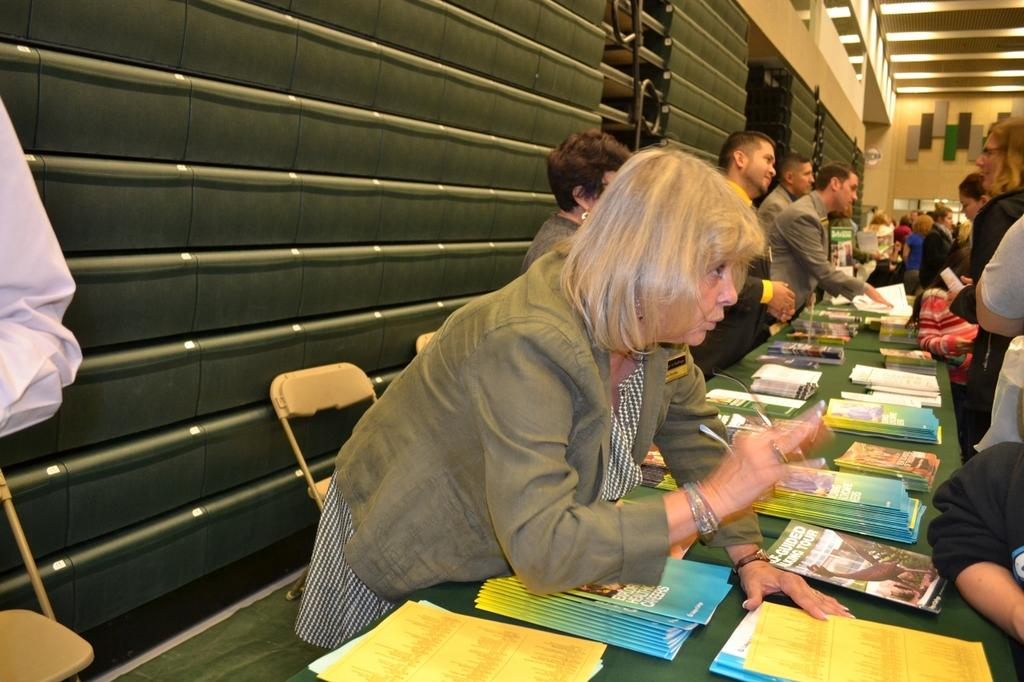Who or what is present in the image? There are people in the image. What items can be seen on the tables? There are books and papers on the tables. What can be seen in the image that provides illumination? There are lights in the image. What is on the wall in the image? There are objects on the wall. What type of science is being discussed in the meeting in the image? There is no meeting present in the image, and therefore no discussion of science can be observed. 